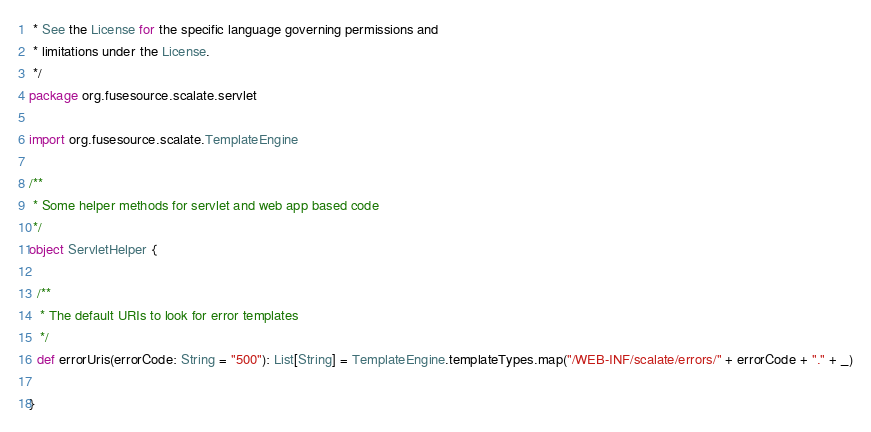<code> <loc_0><loc_0><loc_500><loc_500><_Scala_> * See the License for the specific language governing permissions and
 * limitations under the License.
 */
package org.fusesource.scalate.servlet

import org.fusesource.scalate.TemplateEngine

/**
 * Some helper methods for servlet and web app based code
 */
object ServletHelper {

  /**
   * The default URIs to look for error templates
   */
  def errorUris(errorCode: String = "500"): List[String] = TemplateEngine.templateTypes.map("/WEB-INF/scalate/errors/" + errorCode + "." + _)

}</code> 